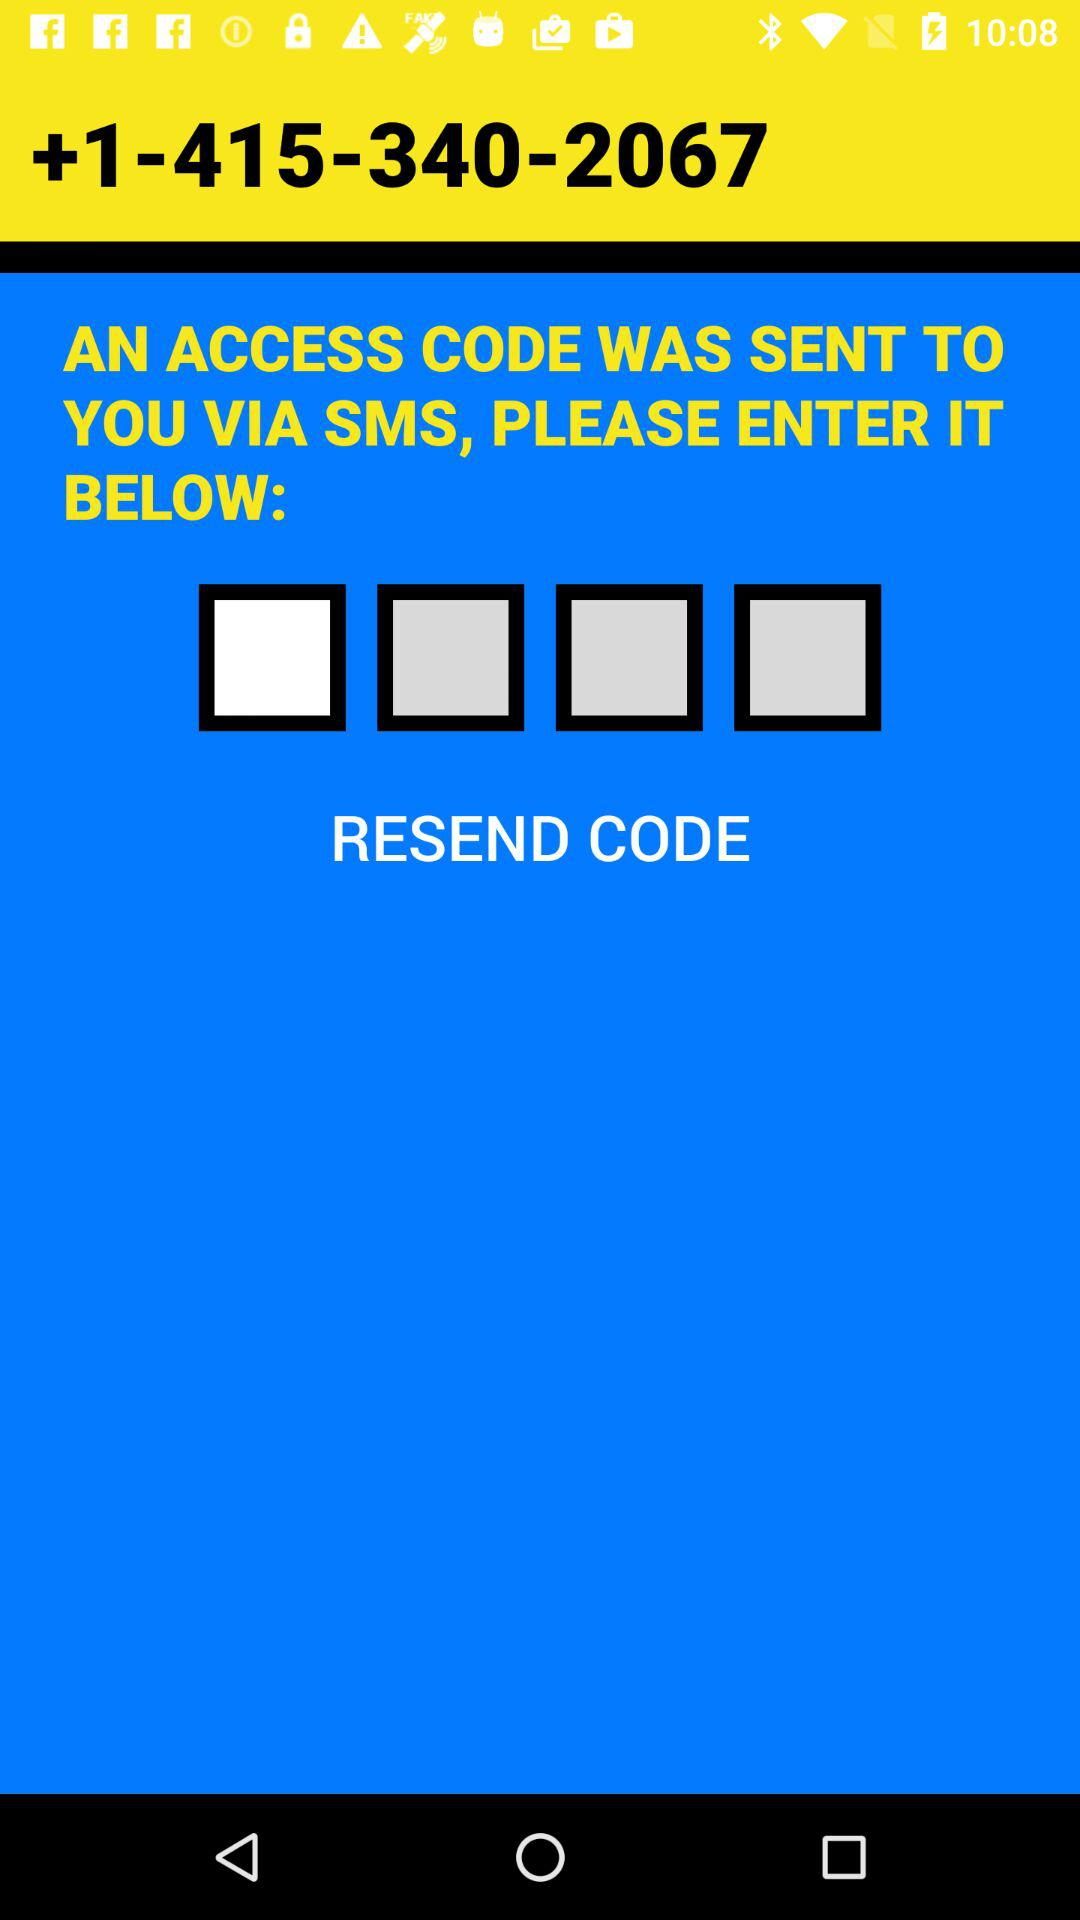To which number has the code been sent? The code has been sent to +1-415-340-2067. 